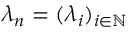<formula> <loc_0><loc_0><loc_500><loc_500>\lambda _ { n } = ( \lambda _ { i } ) _ { i \in \mathbb { N } }</formula> 